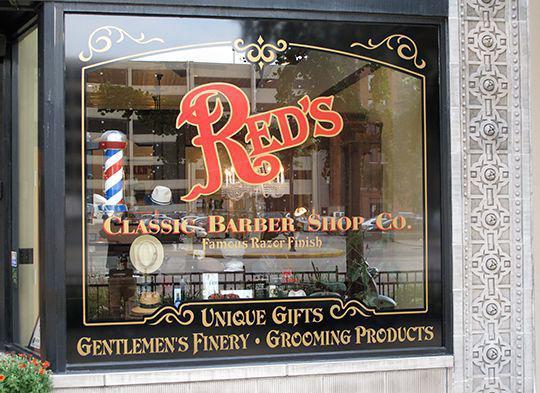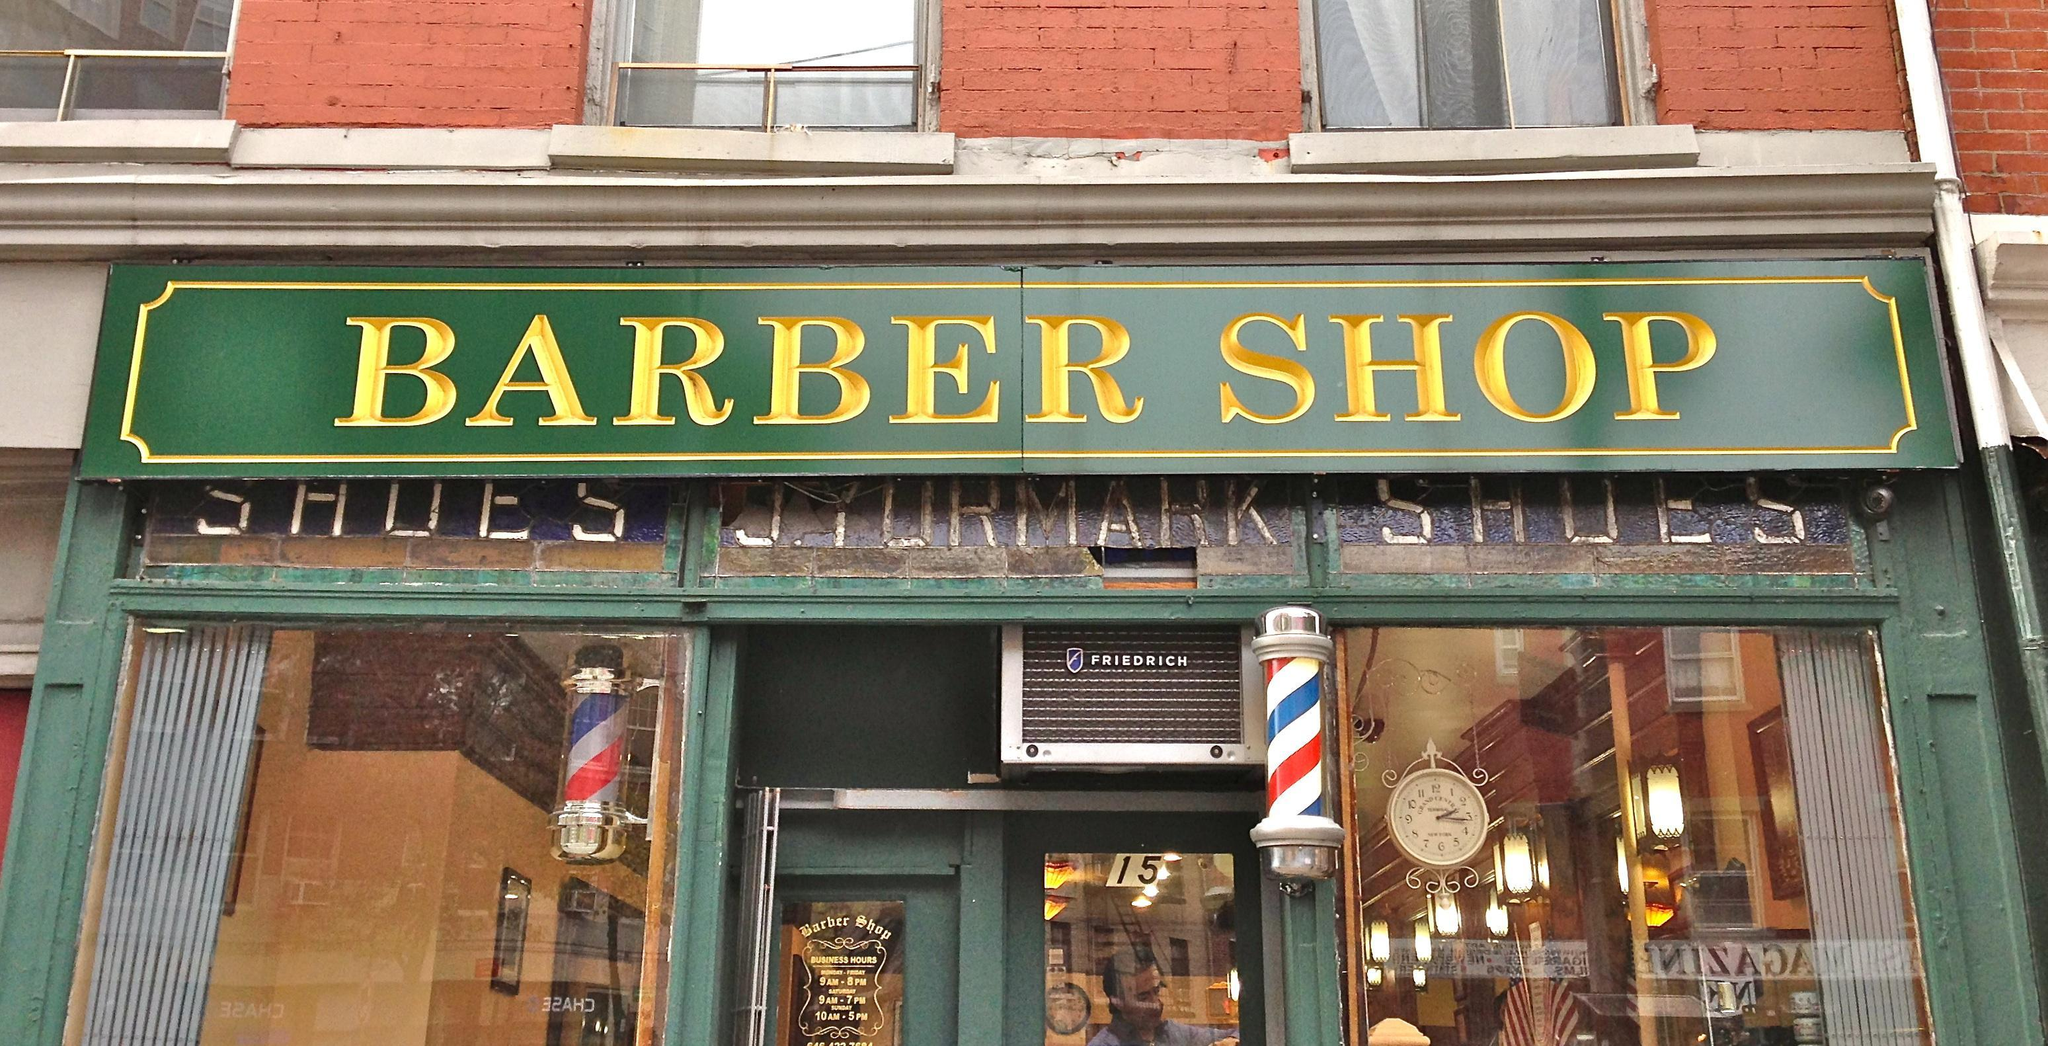The first image is the image on the left, the second image is the image on the right. For the images displayed, is the sentence "Each barber shop displays at least one barber pole." factually correct? Answer yes or no. Yes. 